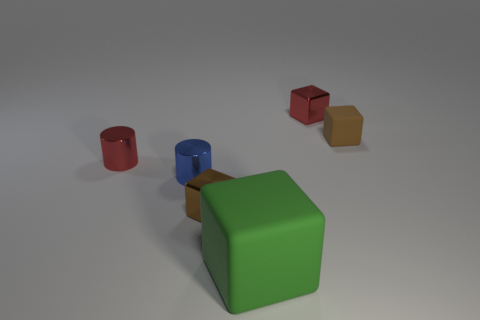There is a tiny cube that is on the left side of the brown matte thing and behind the red metal cylinder; what is its material? The cube in question, located to the left of the brown object and behind the red cylinder, appears to have a metallic surface, which is evident from the reflections and sheen characteristic of metal materials. 